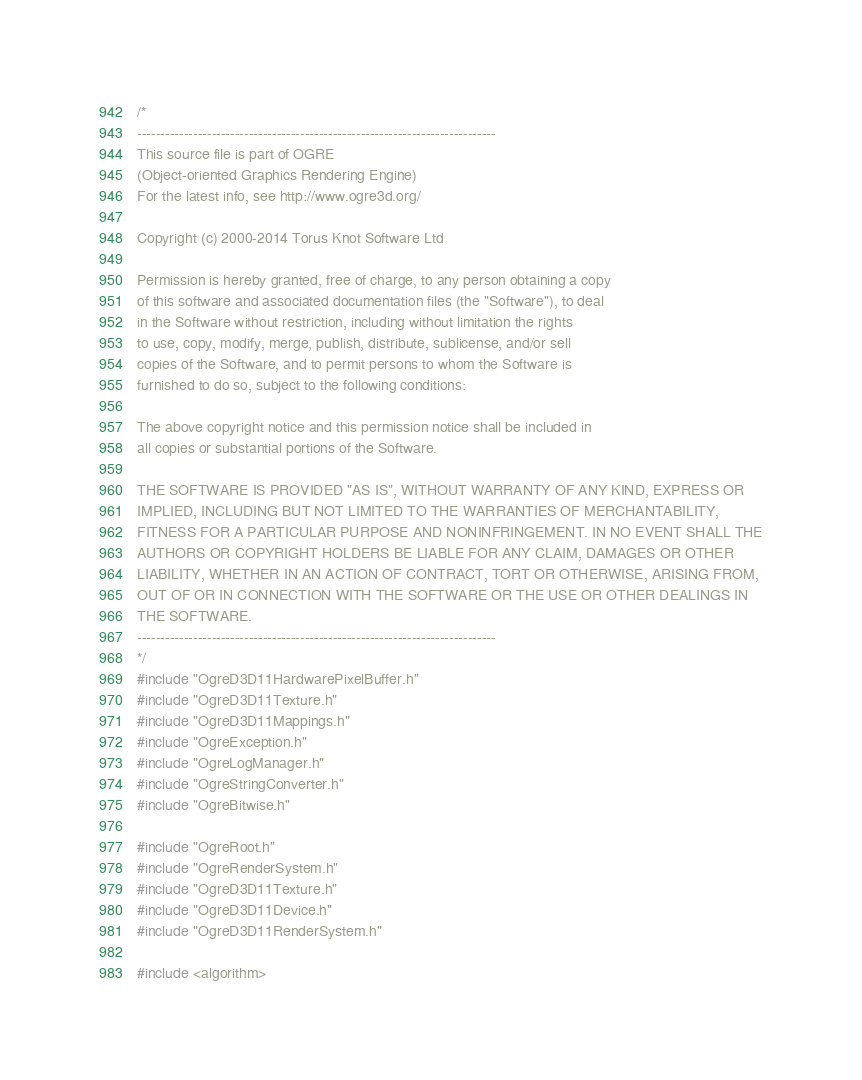<code> <loc_0><loc_0><loc_500><loc_500><_C++_>/*
-----------------------------------------------------------------------------
This source file is part of OGRE
(Object-oriented Graphics Rendering Engine)
For the latest info, see http://www.ogre3d.org/

Copyright (c) 2000-2014 Torus Knot Software Ltd

Permission is hereby granted, free of charge, to any person obtaining a copy
of this software and associated documentation files (the "Software"), to deal
in the Software without restriction, including without limitation the rights
to use, copy, modify, merge, publish, distribute, sublicense, and/or sell
copies of the Software, and to permit persons to whom the Software is
furnished to do so, subject to the following conditions:

The above copyright notice and this permission notice shall be included in
all copies or substantial portions of the Software.

THE SOFTWARE IS PROVIDED "AS IS", WITHOUT WARRANTY OF ANY KIND, EXPRESS OR
IMPLIED, INCLUDING BUT NOT LIMITED TO THE WARRANTIES OF MERCHANTABILITY,
FITNESS FOR A PARTICULAR PURPOSE AND NONINFRINGEMENT. IN NO EVENT SHALL THE
AUTHORS OR COPYRIGHT HOLDERS BE LIABLE FOR ANY CLAIM, DAMAGES OR OTHER
LIABILITY, WHETHER IN AN ACTION OF CONTRACT, TORT OR OTHERWISE, ARISING FROM,
OUT OF OR IN CONNECTION WITH THE SOFTWARE OR THE USE OR OTHER DEALINGS IN
THE SOFTWARE.
-----------------------------------------------------------------------------
*/
#include "OgreD3D11HardwarePixelBuffer.h"
#include "OgreD3D11Texture.h"
#include "OgreD3D11Mappings.h"
#include "OgreException.h"
#include "OgreLogManager.h"
#include "OgreStringConverter.h"
#include "OgreBitwise.h"

#include "OgreRoot.h"
#include "OgreRenderSystem.h"
#include "OgreD3D11Texture.h"
#include "OgreD3D11Device.h"
#include "OgreD3D11RenderSystem.h"

#include <algorithm>
</code> 